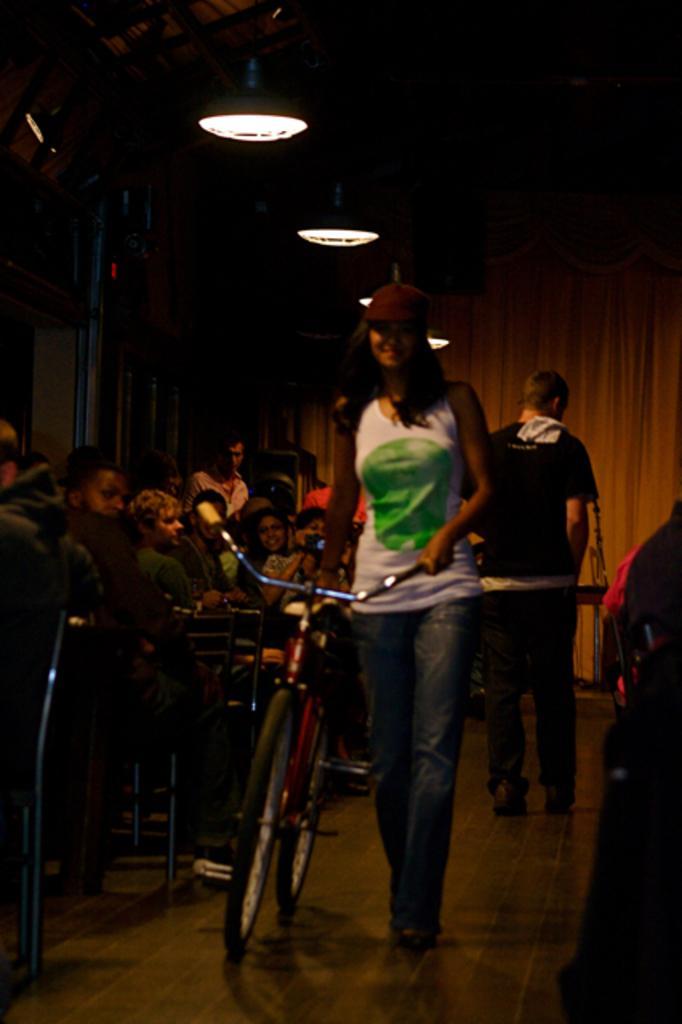Could you give a brief overview of what you see in this image? This picture seems to be clicked inside. In the center there is a woman wearing white color t-shirt, holding a bicycle and seems to be walking on the ground. On the left we can see the group of persons and we can see the chairs. In the background we can see the curtains and lights and some metal rods. 